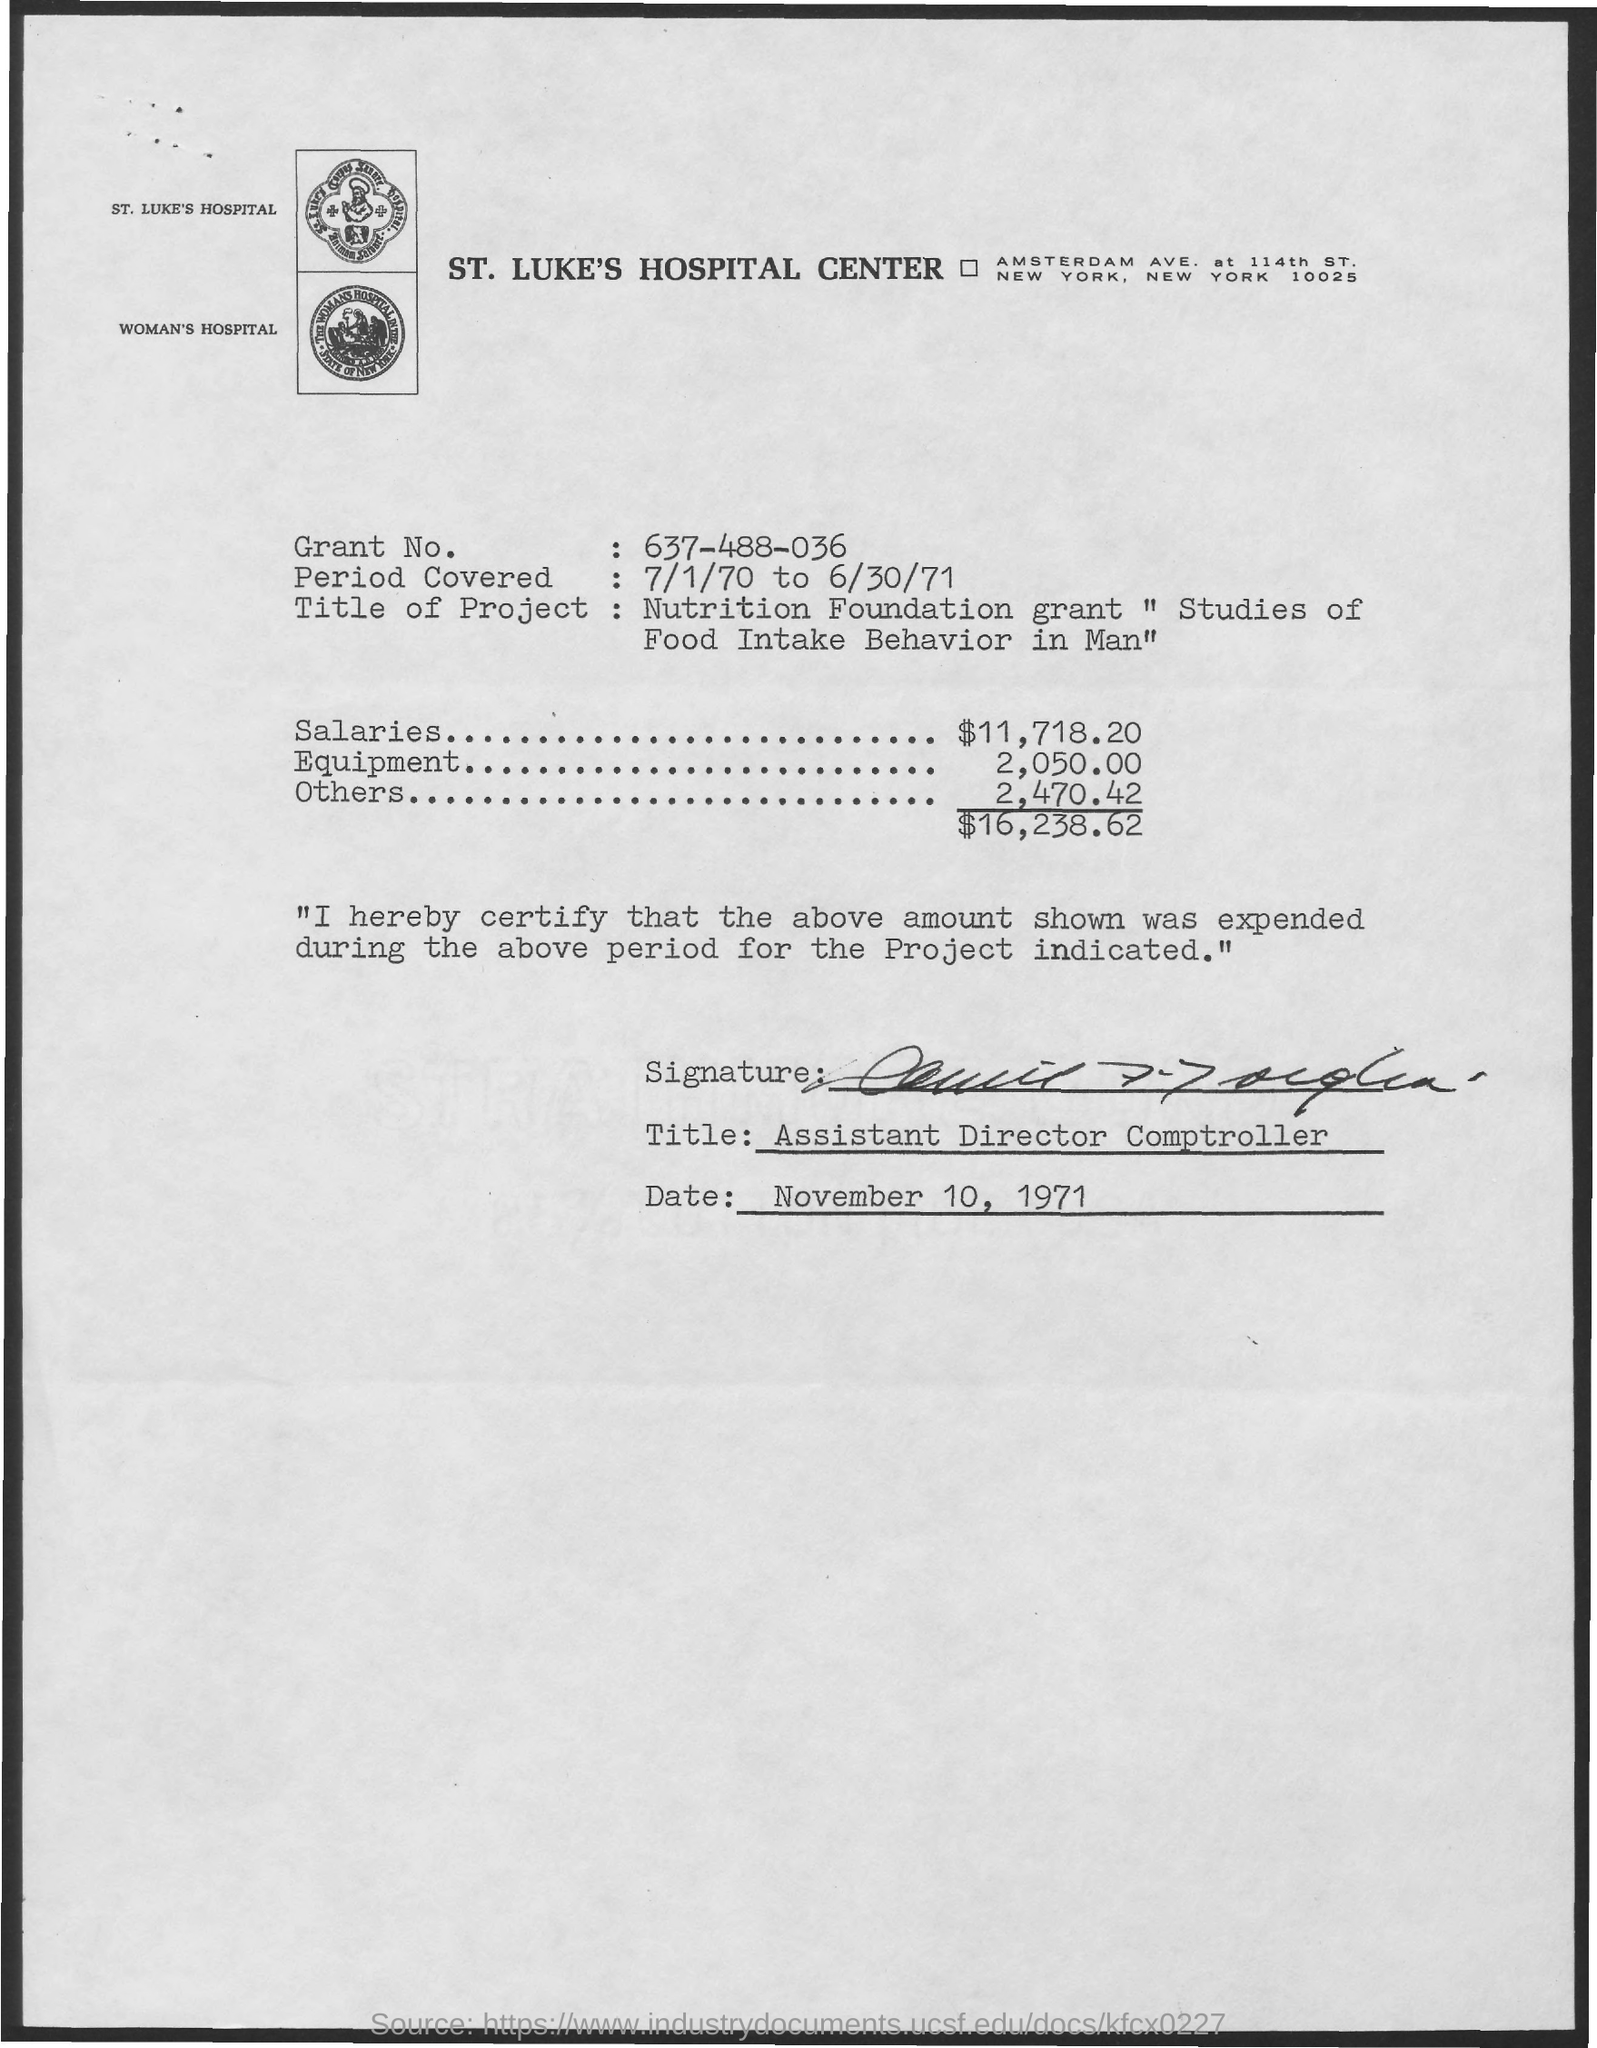What is the name of the hospital center?
Give a very brief answer. St. Luke's Hospital Center. What is the date mentioned at the bottom?
Offer a terse response. November 10, 1971. What is the title mentioned at the bottom?
Offer a terse response. Assistant Director Comptroller. What is the cost of Equipment mentioned here?
Provide a succinct answer. 2,050.00. 